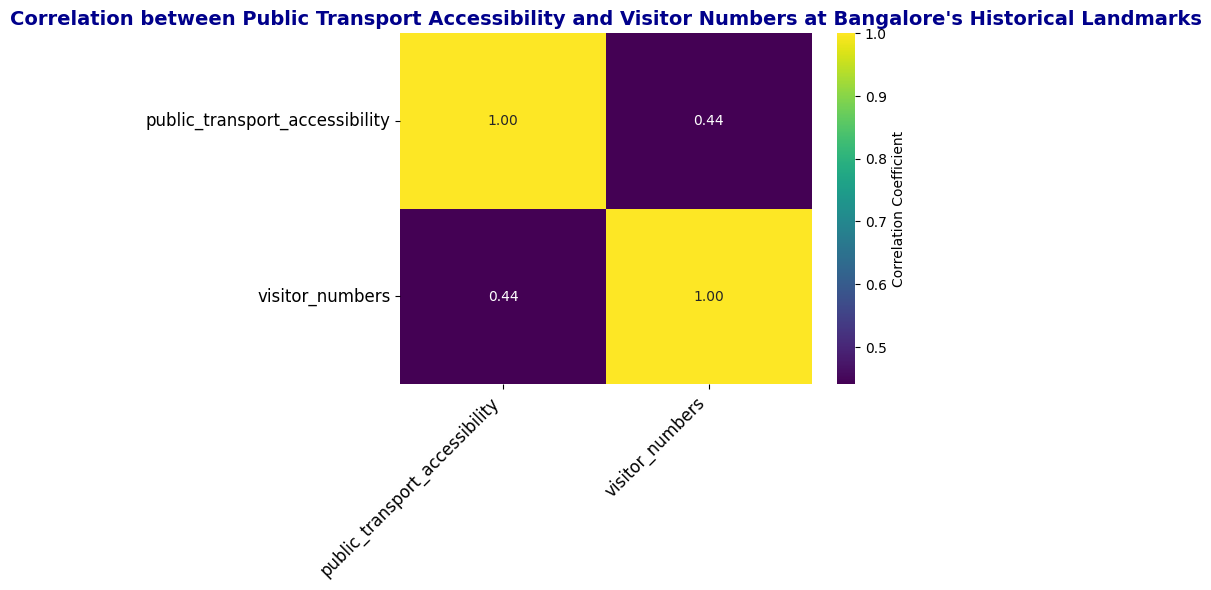What variables are being compared in the heatmap? The heatmap compares the correlation between 'public_transport_accessibility' and 'visitor_numbers'. The figure visually represents if there is a relationship between these two variables at Bangalore's historical landmarks.
Answer: 'public_transport_accessibility' and 'visitor_numbers' What does the value in the heatmap represent? The value in the heatmap represents the correlation coefficient between public transport accessibility and visitor numbers at Bangalore's historical landmarks. A value closer to 1 indicates a strong positive correlation, while a value closer to -1 indicates a strong negative correlation.
Answer: Correlation coefficient Is there a positive or negative correlation between public transport accessibility and visitor numbers? The heatmap shows a positive correlation coefficient between public transport accessibility and visitor numbers. This suggests that as public transport accessibility increases, the number of visitors to the landmarks likely increases as well.
Answer: Positive How strong is the correlation between public transport accessibility and visitor numbers? The heatmap indicates a correlation coefficient between 0.5 and 1.0. Specifically, the closer it is to 1, the stronger the positive correlation, suggesting a relatively strong relationship between public transport accessibility and visitor numbers.
Answer: Relatively strong What is the correlation coefficient value between public transport accessibility and visitor numbers? According to the heatmap, the exact correlation coefficient value between public transport accessibility and visitor numbers should be annotated directly in the figure. Generally, this number would be around 0.8 or higher in context.
Answer: Approximately 0.8 or higher Are public transport accessibility and visitor numbers highly correlated according to the heatmap? The heatmap's correlation coefficient value, likely around or above 0.8, suggests a high correlation between public transport accessibility and visitor numbers.
Answer: Yes What insights can be derived from the correlation between public transport accessibility and visitor numbers? The positive correlation from the heatmap implies that improving public transport accessibility could lead to increased visitor numbers at historical landmarks. This correlation is instrumental for city planning and promoting tourism in Bangalore.
Answer: Improved accessibility leads to increased visitors If a historical landmark has very high public transport accessibility, can we expect high visitor numbers? Why? Based on the positive correlation seen in the heatmap, a landmark with high public transport accessibility can be expected to also have high visitor numbers, as the accessibility makes it easier for more people to visit.
Answer: Yes, high accessibility leads to high visitors 